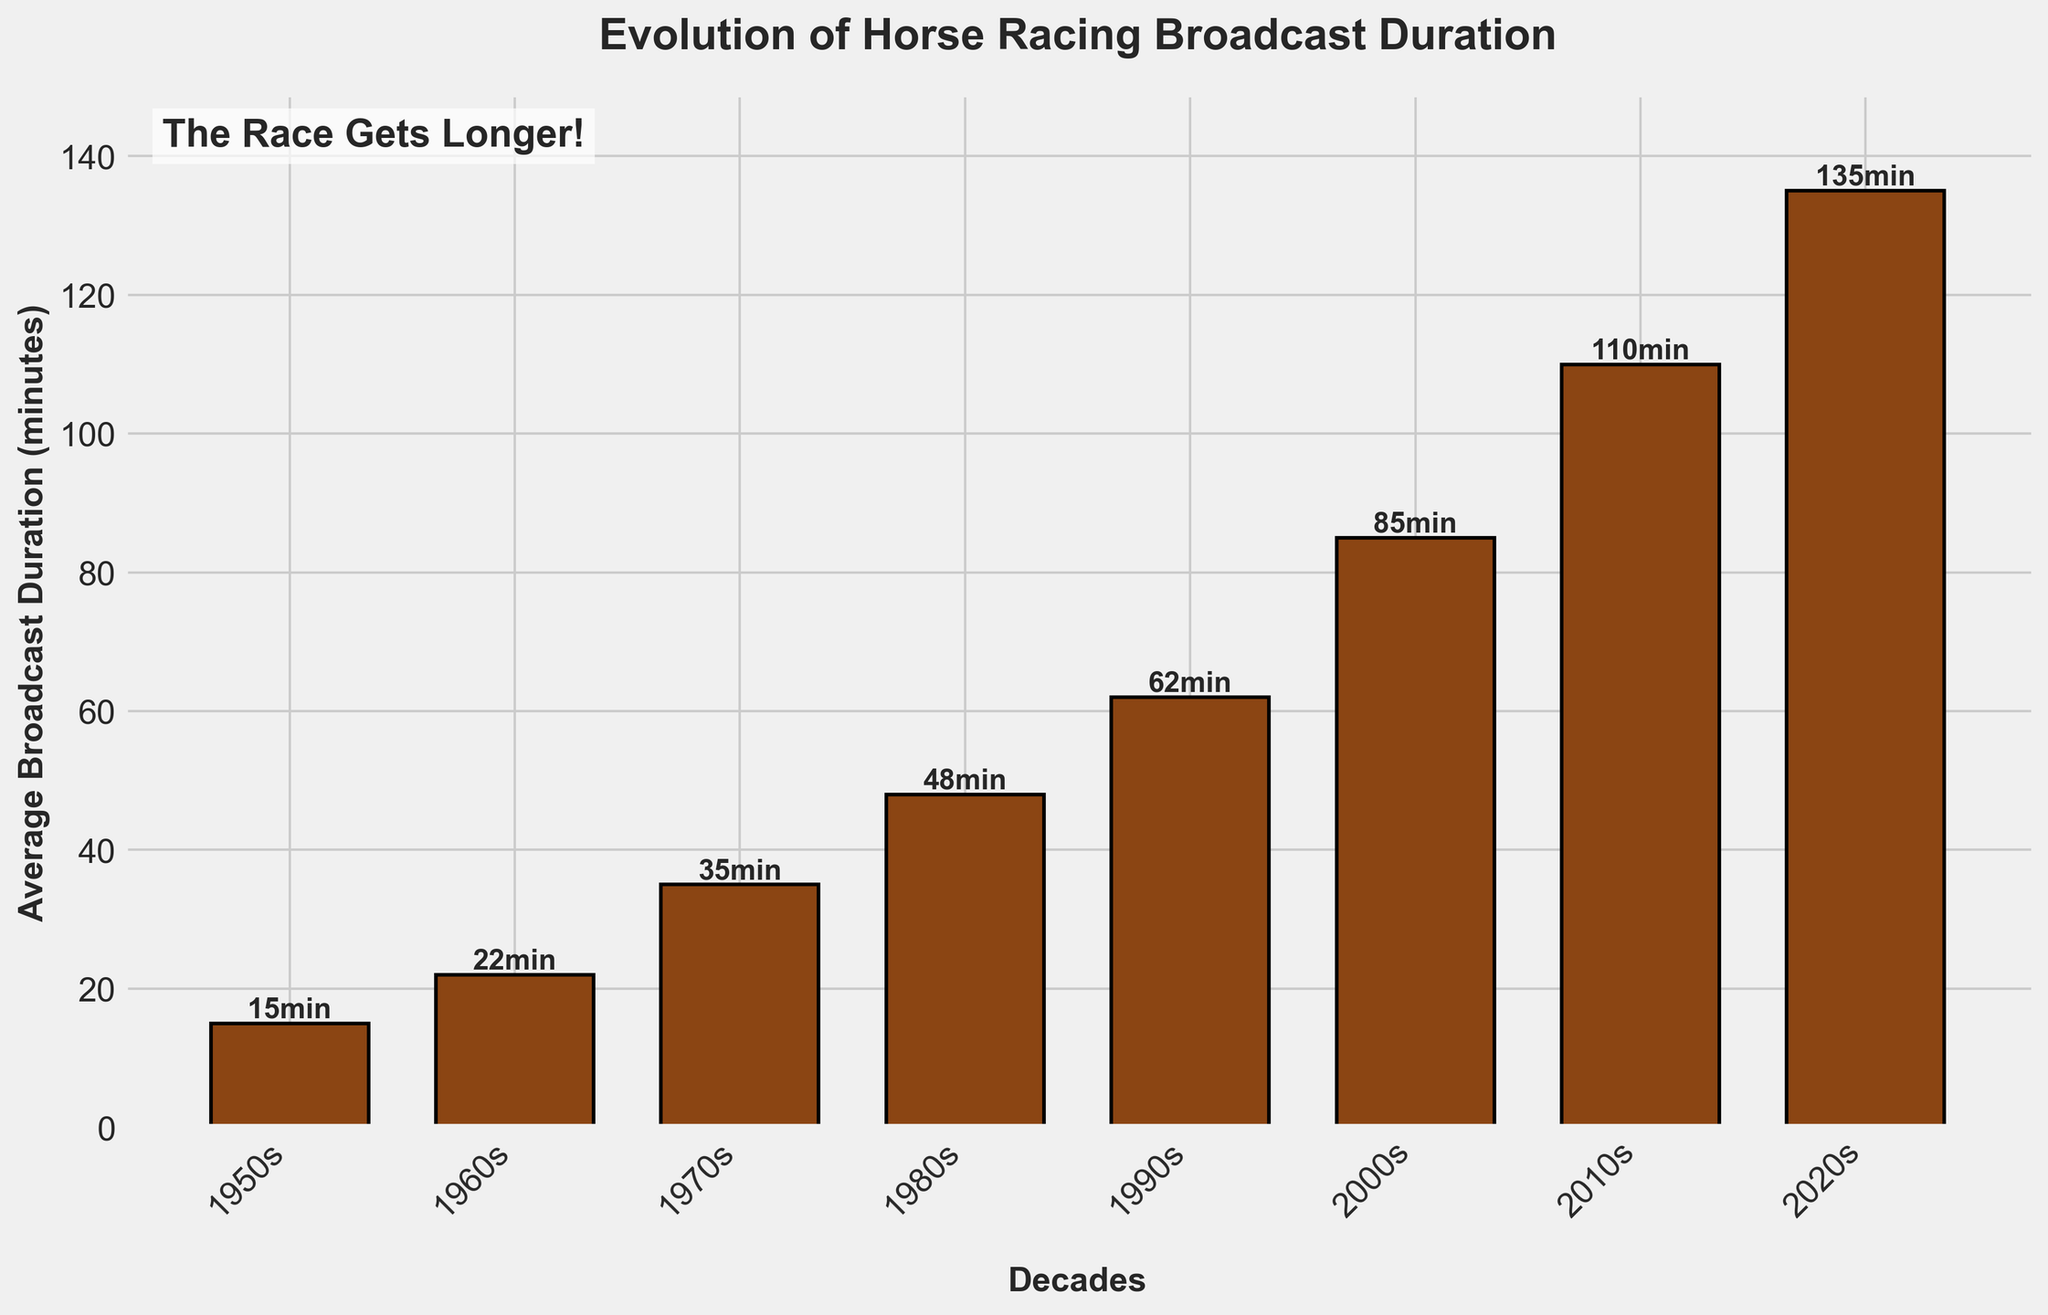What is the average broadcast duration of horse races in the 1970s? The bar representing the 1970s shows a height labeled '35min'. Thus, the average broadcast duration in the 1970s is 35 minutes.
Answer: 35 minutes How much longer is the average broadcast duration in the 2020s compared to the 1960s? The average duration in the 2020s is 135 minutes, and in the 1960s, it is 22 minutes. The difference is 135 - 22 = 113 minutes.
Answer: 113 minutes Between which two consecutive decades did the average broadcast duration increase the most? By comparing each consecutive decades' difference: 1950s-1960s (7 minutes), 1960s-1970s (13 minutes), 1970s-1980s (13 minutes), 1980s-1990s (14 minutes), 1990s-2000s (23 minutes), 2000s-2010s (25 minutes), 2010s-2020s (25 minutes), we see the largest increase is during the transition from 2000s to 2010s and 2010s to 2020s.
Answer: 2000s-2010s and 2010s-2020s Which decade has the highest average broadcast duration? The bar for the 2020s is the tallest, labeled '135min', indicating that the 2020s have the highest average broadcast duration.
Answer: 2020s How does the average broadcast duration in the 1980s compare to the 1990s? The average duration in the 1980s is 48 minutes and in the 1990s is 62 minutes. Subtracting 48 from 62 gives us 14 minutes. Thus, broadcast durations in the 1990s are 14 minutes longer than in the 1980s.
Answer: 14 minutes longer What is the total sum of the average broadcast durations for all the decades depicted? Sum of the values: 15 (1950s) + 22 (1960s) + 35 (1970s) + 48 (1980s) + 62 (1990s) + 85 (2000s) + 110 (2010s) + 135 (2020s) = 512 minutes.
Answer: 512 minutes Are there any decades where the increase in average broadcast duration is the same? If so, which ones? Comparing differences: 1950s-1960s (7 minutes), 1960s-1970s (13 minutes), 1970s-1980s (13 minutes), 1980s-1990s (14 minutes), 1990s-2000s (23 minutes), 2000s-2010s (25 minutes), 2010s-2020s (25 minutes) shows that the increases for 1960s-1970s and 1970s-1980s both are 13 minutes, and the increases for 2000s-2010s and 2010s-2020s both are 25 minutes.
Answer: 1960s-1970s and 1970s-1980s, 2000s-2010s and 2010s-2020s 